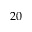<formula> <loc_0><loc_0><loc_500><loc_500>2 0</formula> 